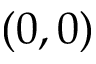<formula> <loc_0><loc_0><loc_500><loc_500>( 0 , 0 )</formula> 